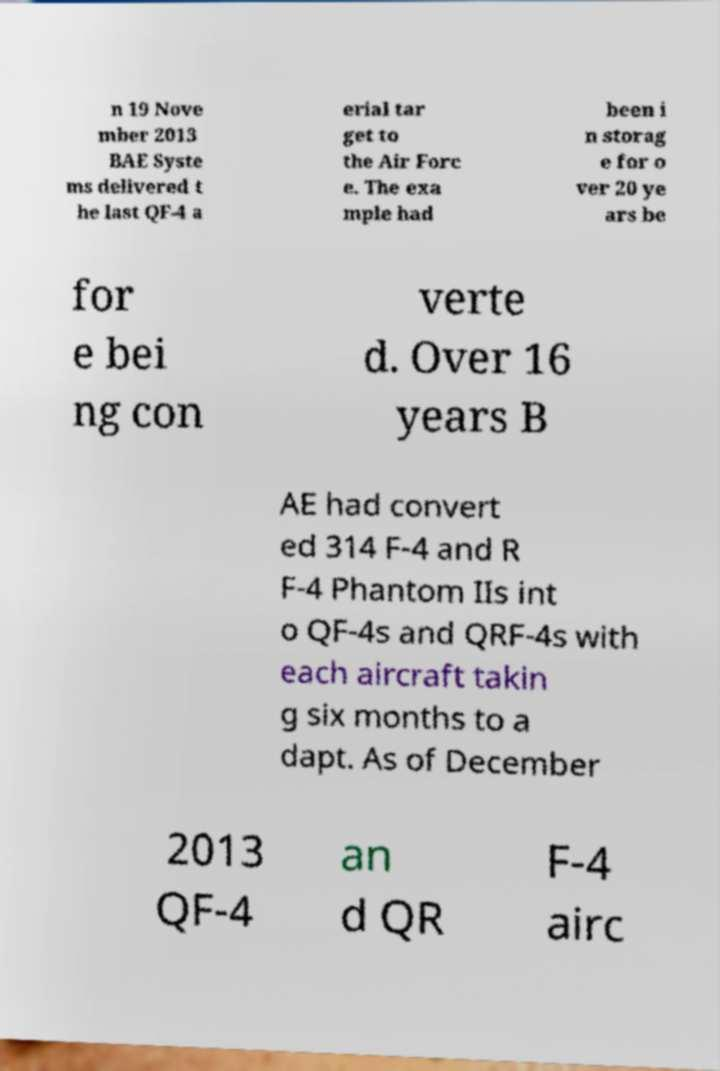What messages or text are displayed in this image? I need them in a readable, typed format. n 19 Nove mber 2013 BAE Syste ms delivered t he last QF-4 a erial tar get to the Air Forc e. The exa mple had been i n storag e for o ver 20 ye ars be for e bei ng con verte d. Over 16 years B AE had convert ed 314 F-4 and R F-4 Phantom IIs int o QF-4s and QRF-4s with each aircraft takin g six months to a dapt. As of December 2013 QF-4 an d QR F-4 airc 